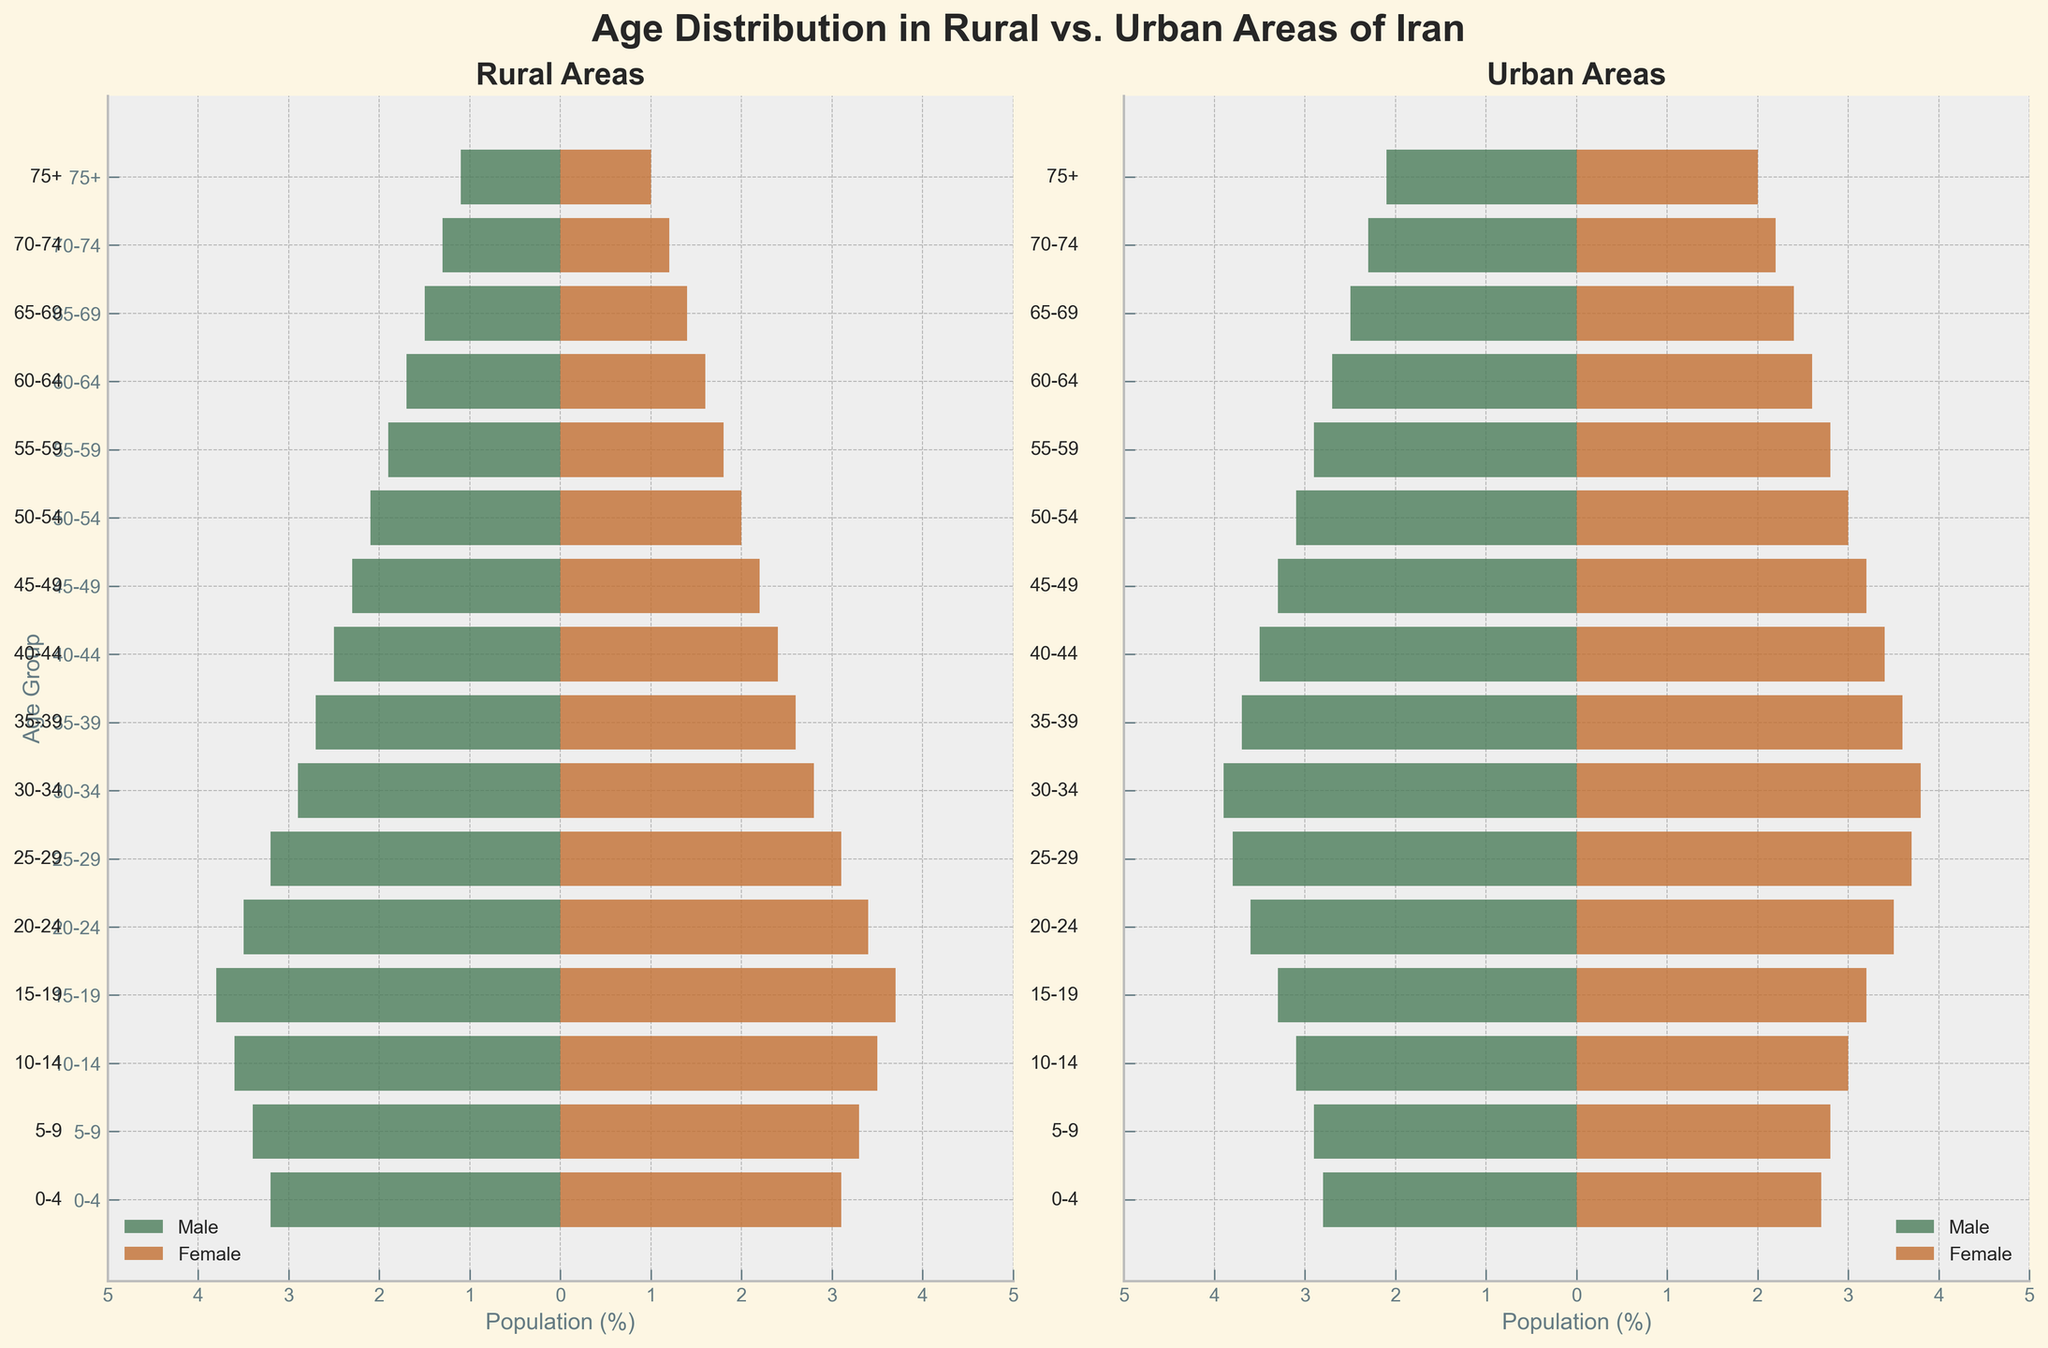What is the title of the figure? The title is usually located at the top center of the figure. In this case, it reads 'Age Distribution in Rural vs. Urban Areas of Iran'.
Answer: Age Distribution in Rural vs. Urban Areas of Iran Which area has a higher percentage of the population in the age group 20-24 for females? The bar for urban females in the age group 20-24 extends further than the bar for rural females in the same age group, indicating a higher percentage.
Answer: Urban In which age group do rural males have the smallest percentage? By examining the lengths of the bars, the shortest bar for rural males is in the '75+' age group.
Answer: 75+ How do the percentages of rural and urban males compare in the age group 15-19? For the age group 15-19, the rural male bar reaches 3.8% while the urban male bar reaches 3.3%. Rural males have a 0.5% higher percentage in this age group.
Answer: Rural is higher by 0.5% What is the total percentage of urban females in the age groups 50-54 and 55-59? The percentages of urban females in these age groups are 3.0% and 2.8%. Adding them gives a total of 5.8%.
Answer: 5.8% Which age group has the same percentage for rural females and urban females? By inspecting the figure, the age group 65-69 shows that both rural and urban females have the same percentage of 1.4%.
Answer: 65-69 Are there more rural males or urban males in the age group 30-34? Comparing the length of bars in the age group 30-34, urban males have a higher percentage (3.9%) compared to rural males (2.9%).
Answer: Urban males What is the combined percentage of rural males and females in the age group 0-4? The percentages for rural males and females in this age group are 3.2% and 3.1%, respectively. Adding these gives a combined total of 6.3%.
Answer: 6.3% How does the population distribution for rural females change from the age group 10-14 to 20-24? The percentages for rural females in the age groups 10-14, 15-19, and 20-24 are 3.5%, 3.7%, and 3.4%, respectively. This shows that the percentage increases from 10-14 to 15-19 and then decreases slightly in 20-24.
Answer: Increased then decreased 